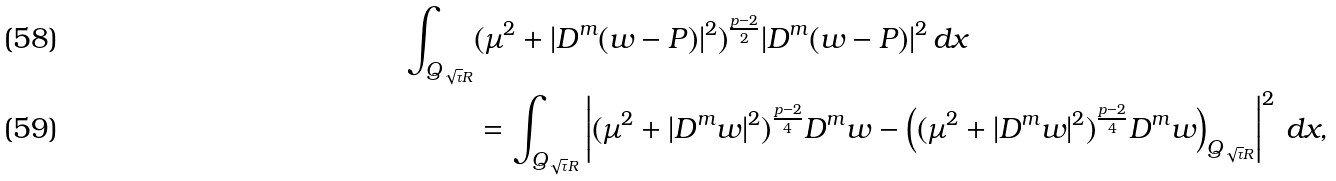Convert formula to latex. <formula><loc_0><loc_0><loc_500><loc_500>\int _ { Q _ { \sqrt { \tau } R } } & ( \mu ^ { 2 } + | D ^ { m } ( w - P ) | ^ { 2 } ) ^ { \frac { p - 2 } { 2 } } | D ^ { m } ( w - P ) | ^ { 2 } \, d x \\ & = \int _ { Q _ { \sqrt { \tau } R } } \left | ( \mu ^ { 2 } + | D ^ { m } w | ^ { 2 } ) ^ { \frac { p - 2 } { 4 } } D ^ { m } w - \left ( ( \mu ^ { 2 } + | D ^ { m } w | ^ { 2 } ) ^ { \frac { p - 2 } { 4 } } D ^ { m } w \right ) _ { Q _ { \sqrt { \tau } R } } \right | ^ { 2 } \, d x ,</formula> 